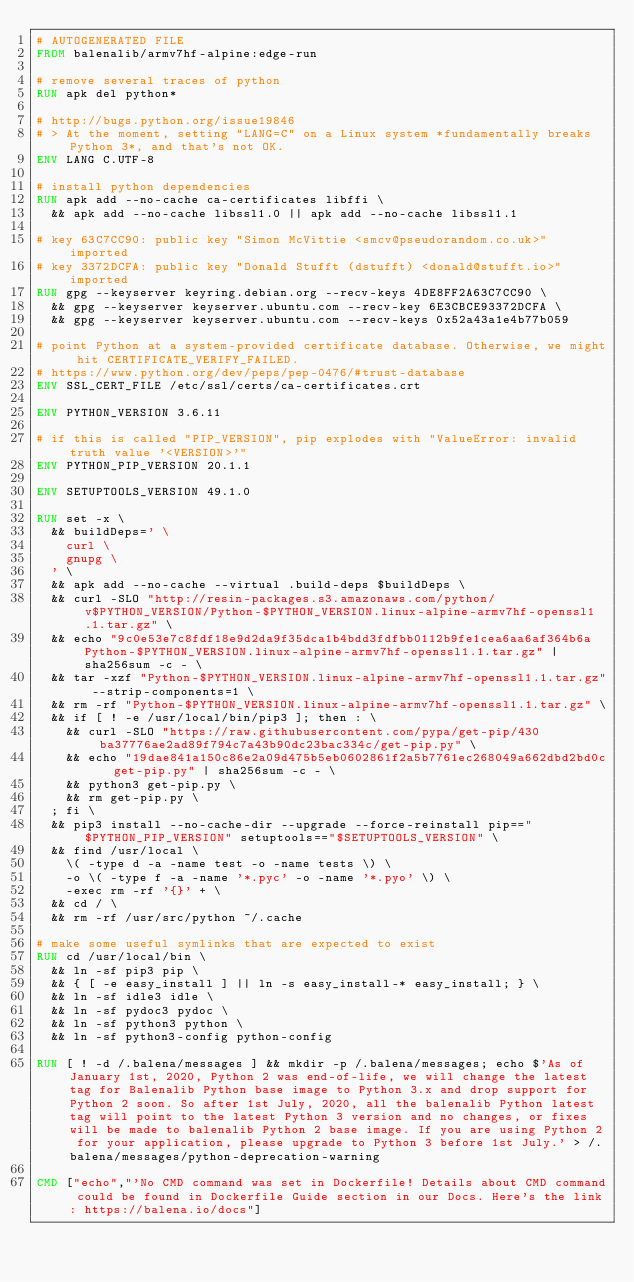Convert code to text. <code><loc_0><loc_0><loc_500><loc_500><_Dockerfile_># AUTOGENERATED FILE
FROM balenalib/armv7hf-alpine:edge-run

# remove several traces of python
RUN apk del python*

# http://bugs.python.org/issue19846
# > At the moment, setting "LANG=C" on a Linux system *fundamentally breaks Python 3*, and that's not OK.
ENV LANG C.UTF-8

# install python dependencies
RUN apk add --no-cache ca-certificates libffi \
	&& apk add --no-cache libssl1.0 || apk add --no-cache libssl1.1

# key 63C7CC90: public key "Simon McVittie <smcv@pseudorandom.co.uk>" imported
# key 3372DCFA: public key "Donald Stufft (dstufft) <donald@stufft.io>" imported
RUN gpg --keyserver keyring.debian.org --recv-keys 4DE8FF2A63C7CC90 \
	&& gpg --keyserver keyserver.ubuntu.com --recv-key 6E3CBCE93372DCFA \
	&& gpg --keyserver keyserver.ubuntu.com --recv-keys 0x52a43a1e4b77b059

# point Python at a system-provided certificate database. Otherwise, we might hit CERTIFICATE_VERIFY_FAILED.
# https://www.python.org/dev/peps/pep-0476/#trust-database
ENV SSL_CERT_FILE /etc/ssl/certs/ca-certificates.crt

ENV PYTHON_VERSION 3.6.11

# if this is called "PIP_VERSION", pip explodes with "ValueError: invalid truth value '<VERSION>'"
ENV PYTHON_PIP_VERSION 20.1.1

ENV SETUPTOOLS_VERSION 49.1.0

RUN set -x \
	&& buildDeps=' \
		curl \
		gnupg \
	' \
	&& apk add --no-cache --virtual .build-deps $buildDeps \
	&& curl -SLO "http://resin-packages.s3.amazonaws.com/python/v$PYTHON_VERSION/Python-$PYTHON_VERSION.linux-alpine-armv7hf-openssl1.1.tar.gz" \
	&& echo "9c0e53e7c8fdf18e9d2da9f35dca1b4bdd3fdfbb0112b9fe1cea6aa6af364b6a  Python-$PYTHON_VERSION.linux-alpine-armv7hf-openssl1.1.tar.gz" | sha256sum -c - \
	&& tar -xzf "Python-$PYTHON_VERSION.linux-alpine-armv7hf-openssl1.1.tar.gz" --strip-components=1 \
	&& rm -rf "Python-$PYTHON_VERSION.linux-alpine-armv7hf-openssl1.1.tar.gz" \
	&& if [ ! -e /usr/local/bin/pip3 ]; then : \
		&& curl -SLO "https://raw.githubusercontent.com/pypa/get-pip/430ba37776ae2ad89f794c7a43b90dc23bac334c/get-pip.py" \
		&& echo "19dae841a150c86e2a09d475b5eb0602861f2a5b7761ec268049a662dbd2bd0c  get-pip.py" | sha256sum -c - \
		&& python3 get-pip.py \
		&& rm get-pip.py \
	; fi \
	&& pip3 install --no-cache-dir --upgrade --force-reinstall pip=="$PYTHON_PIP_VERSION" setuptools=="$SETUPTOOLS_VERSION" \
	&& find /usr/local \
		\( -type d -a -name test -o -name tests \) \
		-o \( -type f -a -name '*.pyc' -o -name '*.pyo' \) \
		-exec rm -rf '{}' + \
	&& cd / \
	&& rm -rf /usr/src/python ~/.cache

# make some useful symlinks that are expected to exist
RUN cd /usr/local/bin \
	&& ln -sf pip3 pip \
	&& { [ -e easy_install ] || ln -s easy_install-* easy_install; } \
	&& ln -sf idle3 idle \
	&& ln -sf pydoc3 pydoc \
	&& ln -sf python3 python \
	&& ln -sf python3-config python-config

RUN [ ! -d /.balena/messages ] && mkdir -p /.balena/messages; echo $'As of January 1st, 2020, Python 2 was end-of-life, we will change the latest tag for Balenalib Python base image to Python 3.x and drop support for Python 2 soon. So after 1st July, 2020, all the balenalib Python latest tag will point to the latest Python 3 version and no changes, or fixes will be made to balenalib Python 2 base image. If you are using Python 2 for your application, please upgrade to Python 3 before 1st July.' > /.balena/messages/python-deprecation-warning

CMD ["echo","'No CMD command was set in Dockerfile! Details about CMD command could be found in Dockerfile Guide section in our Docs. Here's the link: https://balena.io/docs"]
</code> 